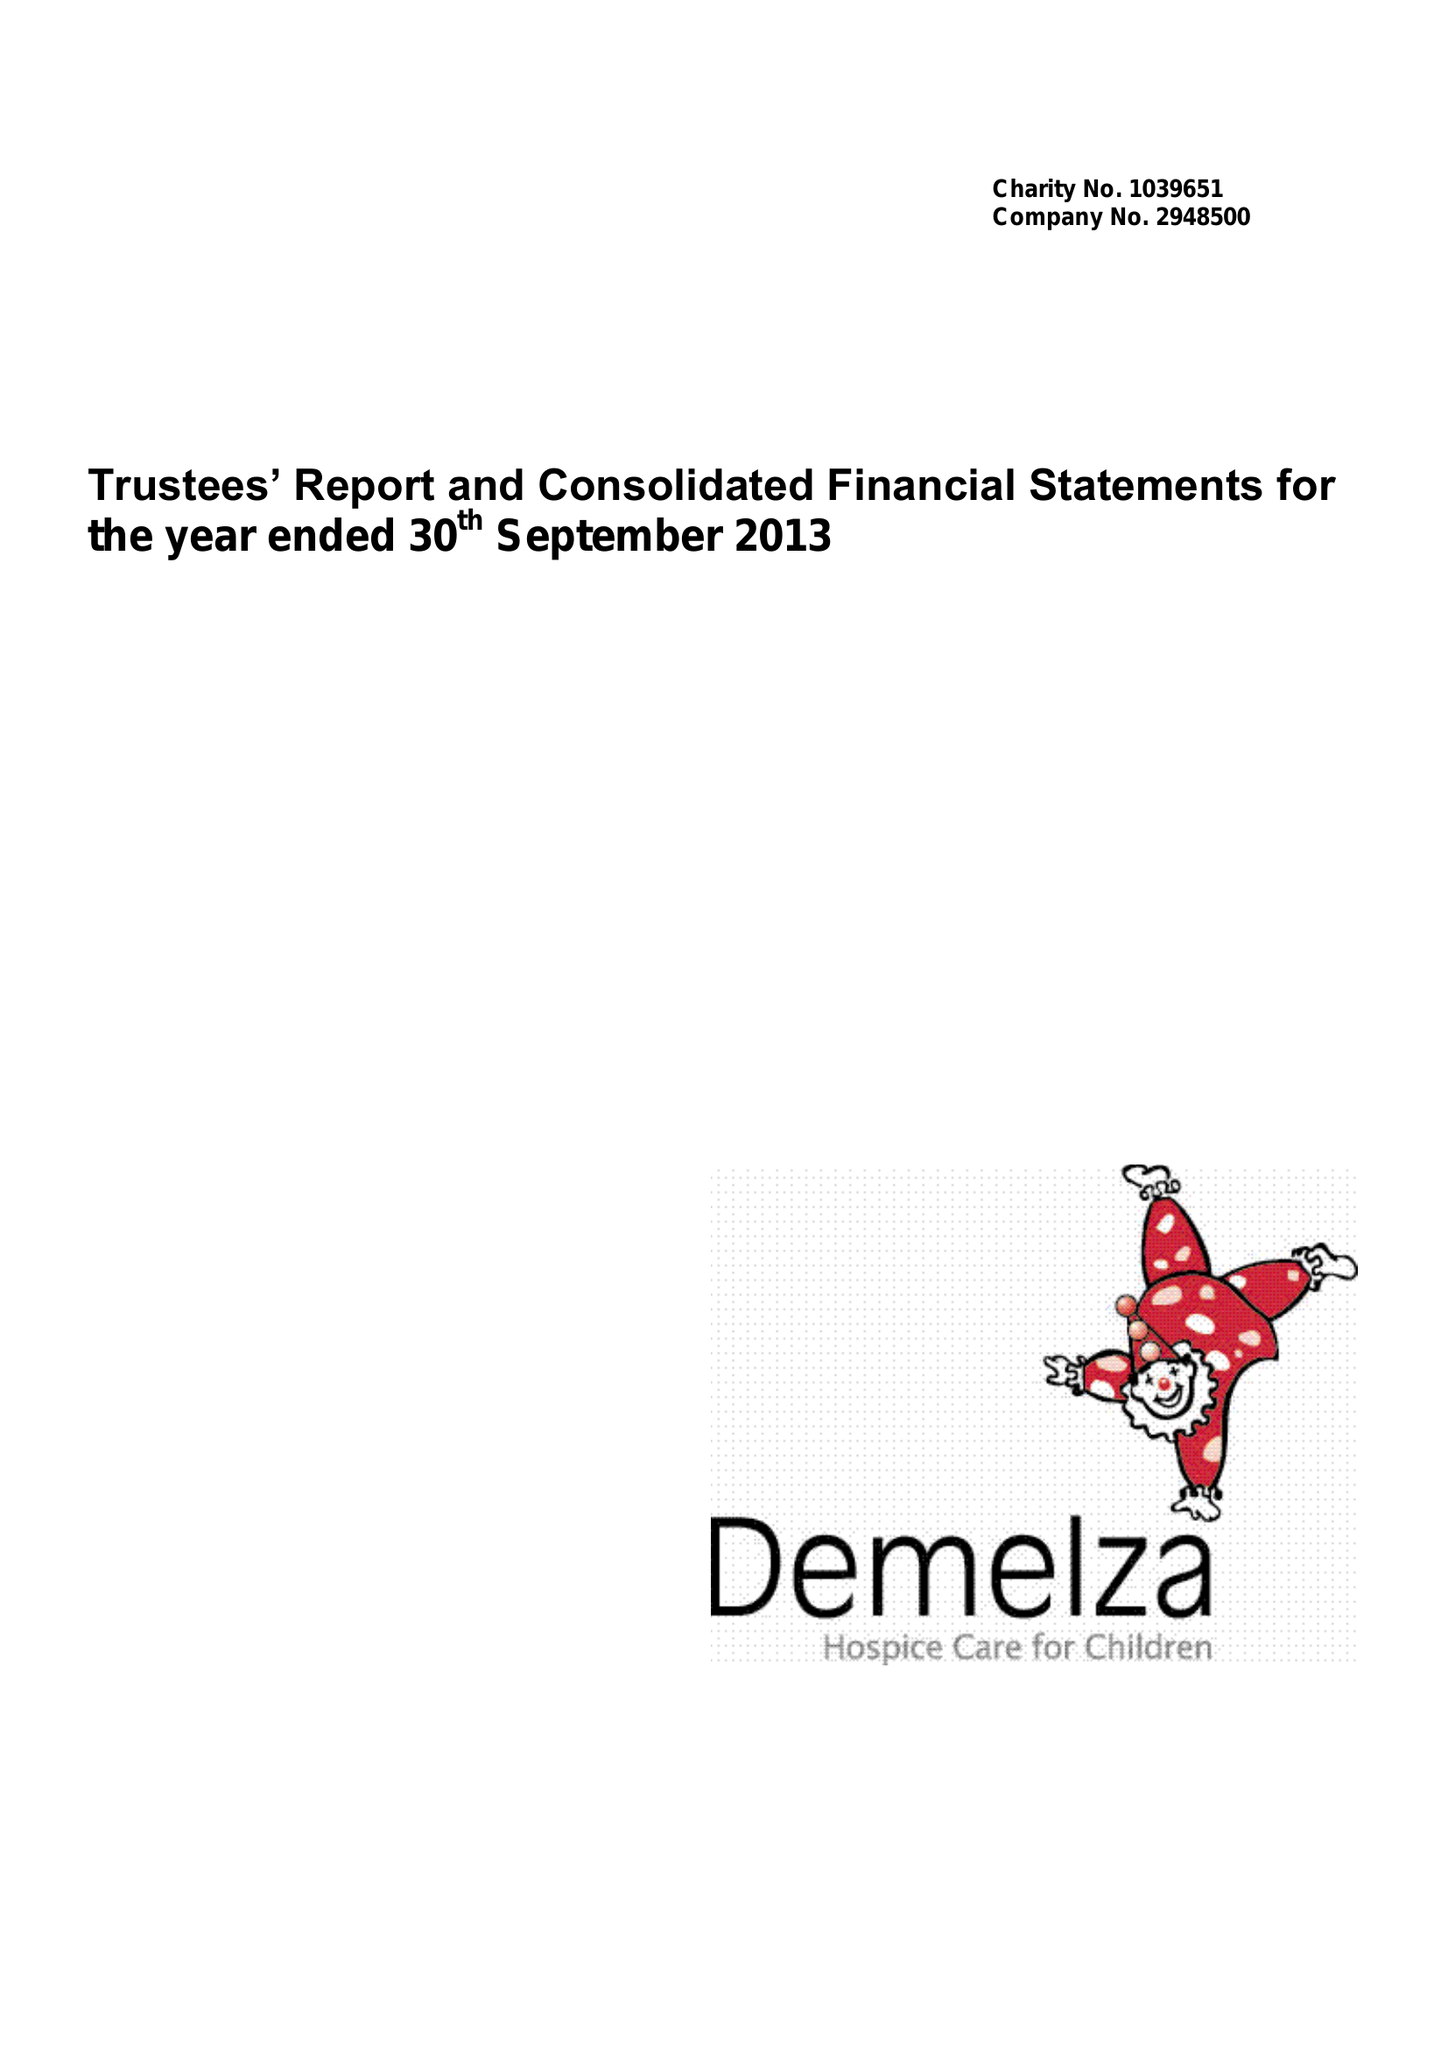What is the value for the charity_number?
Answer the question using a single word or phrase. 1039651 